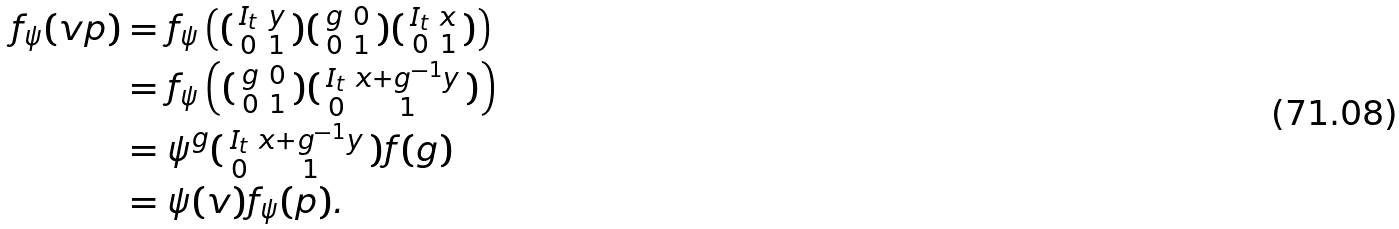<formula> <loc_0><loc_0><loc_500><loc_500>f _ { \psi } ( v p ) & = f _ { \psi } \left ( ( \begin{smallmatrix} I _ { t } & y \\ 0 & 1 \end{smallmatrix} ) ( \begin{smallmatrix} g & 0 \\ 0 & 1 \end{smallmatrix} ) ( \begin{smallmatrix} I _ { t } & x \\ 0 & 1 \end{smallmatrix} ) \right ) \\ & = f _ { \psi } \left ( ( \begin{smallmatrix} g & 0 \\ 0 & 1 \end{smallmatrix} ) ( \begin{smallmatrix} I _ { t } & x + g ^ { - 1 } y \\ 0 & 1 \end{smallmatrix} ) \right ) \\ & = \psi ^ { g } ( \begin{smallmatrix} I _ { t } & x + g ^ { - 1 } y \\ 0 & 1 \end{smallmatrix} ) f ( g ) \\ & = \psi ( v ) f _ { \psi } ( p ) .</formula> 